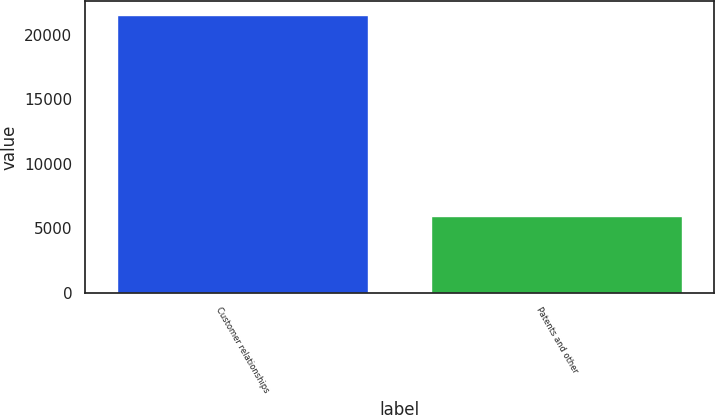Convert chart. <chart><loc_0><loc_0><loc_500><loc_500><bar_chart><fcel>Customer relationships<fcel>Patents and other<nl><fcel>21510<fcel>5966<nl></chart> 